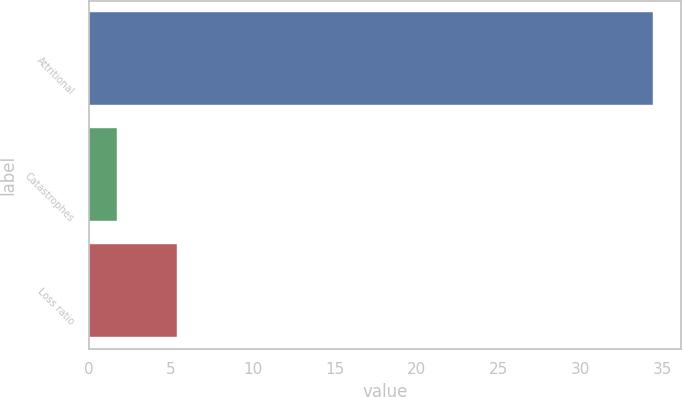Convert chart. <chart><loc_0><loc_0><loc_500><loc_500><bar_chart><fcel>Attritional<fcel>Catastrophes<fcel>Loss ratio<nl><fcel>34.4<fcel>1.7<fcel>5.4<nl></chart> 